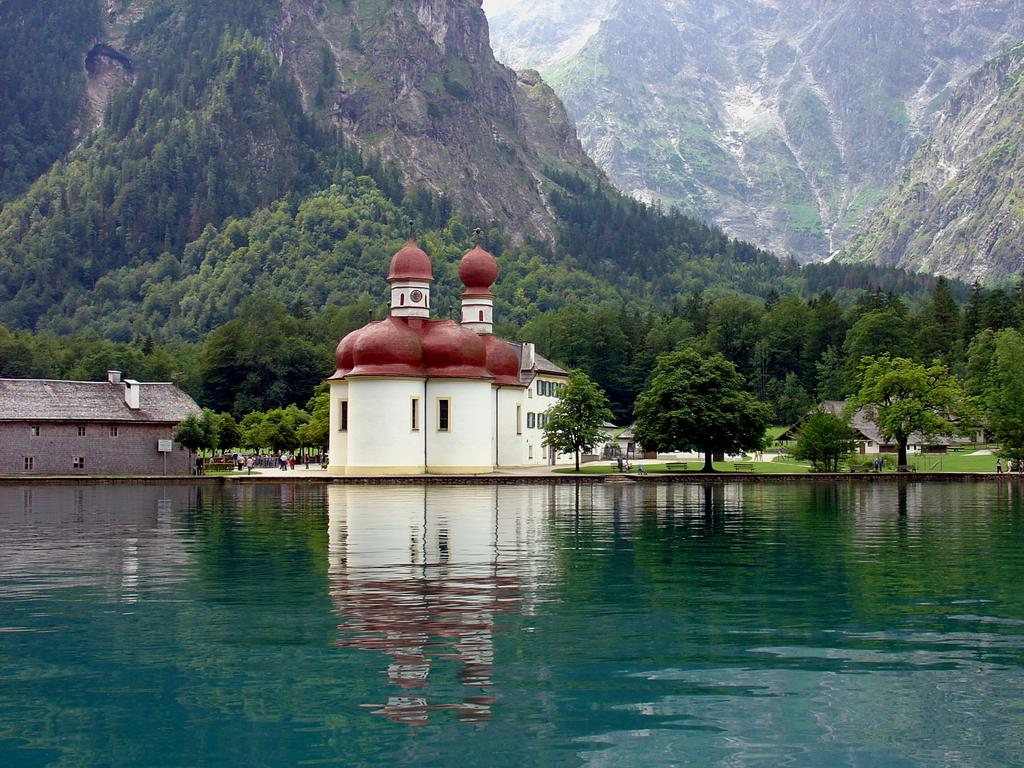What is visible in the image? Water, houses, people walking, benches, grass, and hills in the background are visible in the image. Can you describe the setting of the image? The image shows a scene with water, houses, and people walking, suggesting it might be a park or a recreational area. What type of seating is available in the image? There are benches present in the image. What can be seen in the background of the image? Hills are visible in the background of the image. What type of mask is being worn by the person in the middle of the image? There is no person wearing a mask in the image; the focus is on the water, houses, people walking, benches, grass, and hills in the background. 